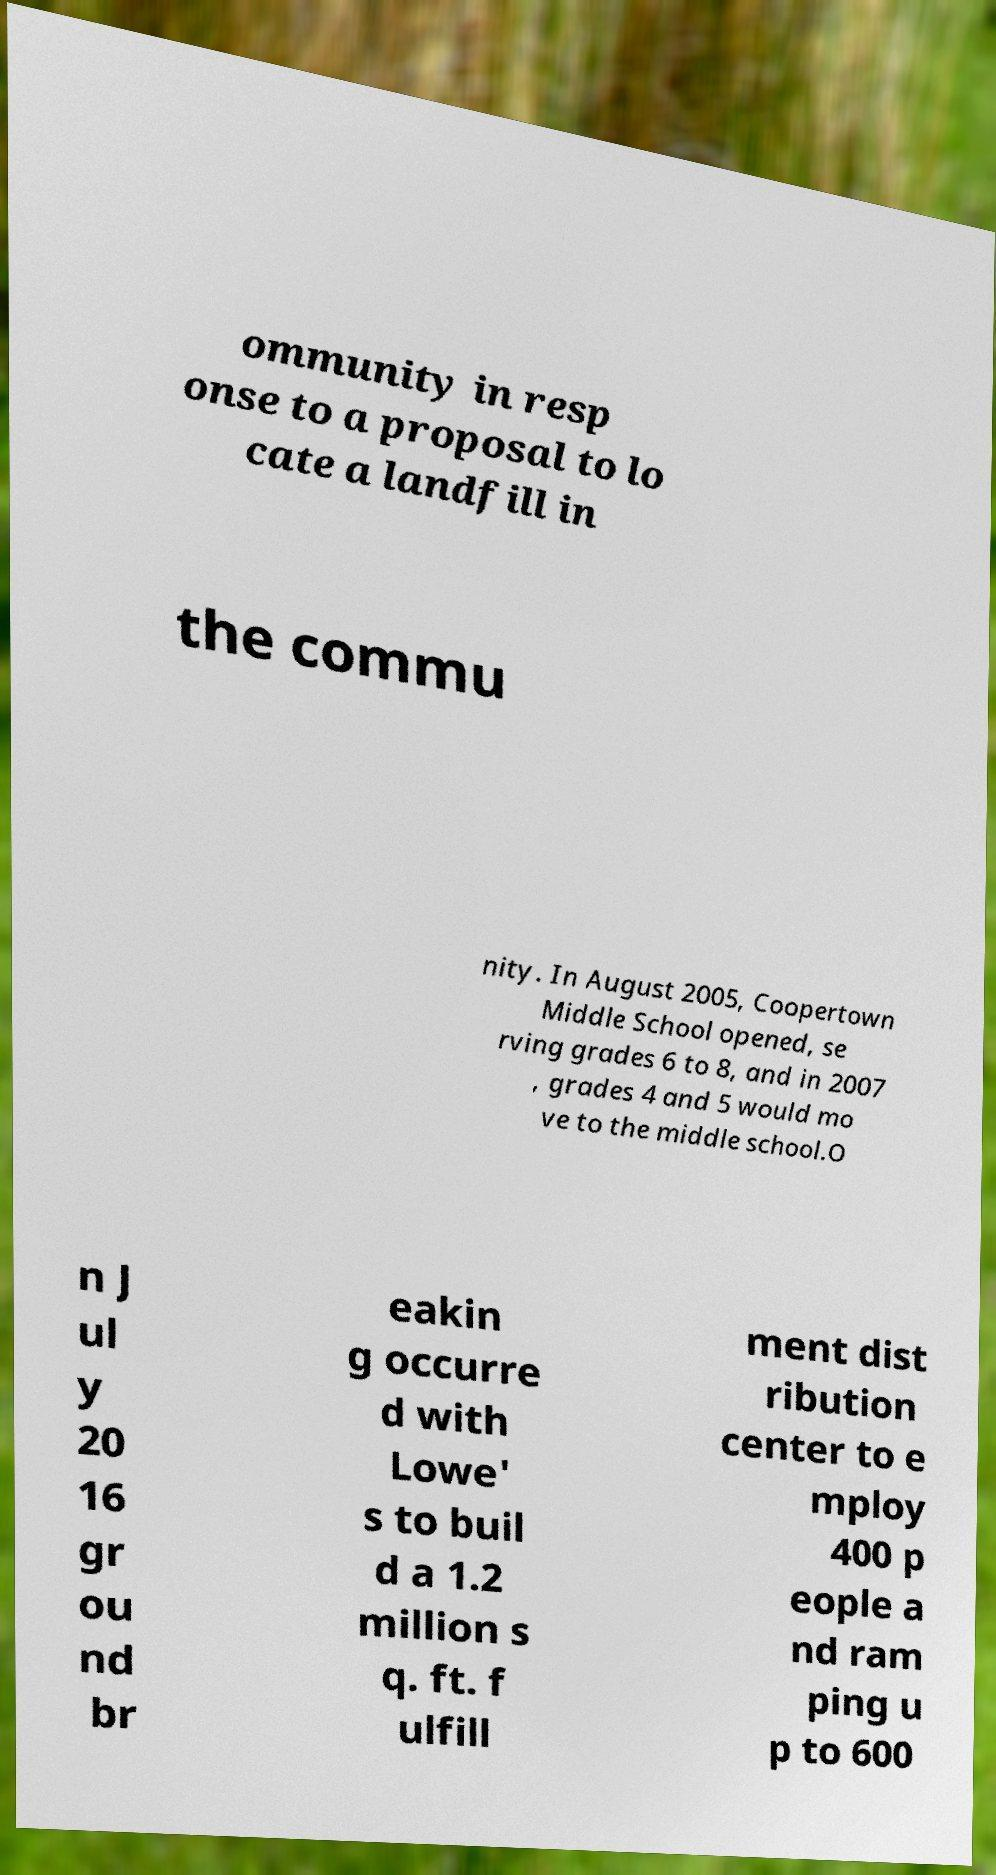What messages or text are displayed in this image? I need them in a readable, typed format. ommunity in resp onse to a proposal to lo cate a landfill in the commu nity. In August 2005, Coopertown Middle School opened, se rving grades 6 to 8, and in 2007 , grades 4 and 5 would mo ve to the middle school.O n J ul y 20 16 gr ou nd br eakin g occurre d with Lowe' s to buil d a 1.2 million s q. ft. f ulfill ment dist ribution center to e mploy 400 p eople a nd ram ping u p to 600 